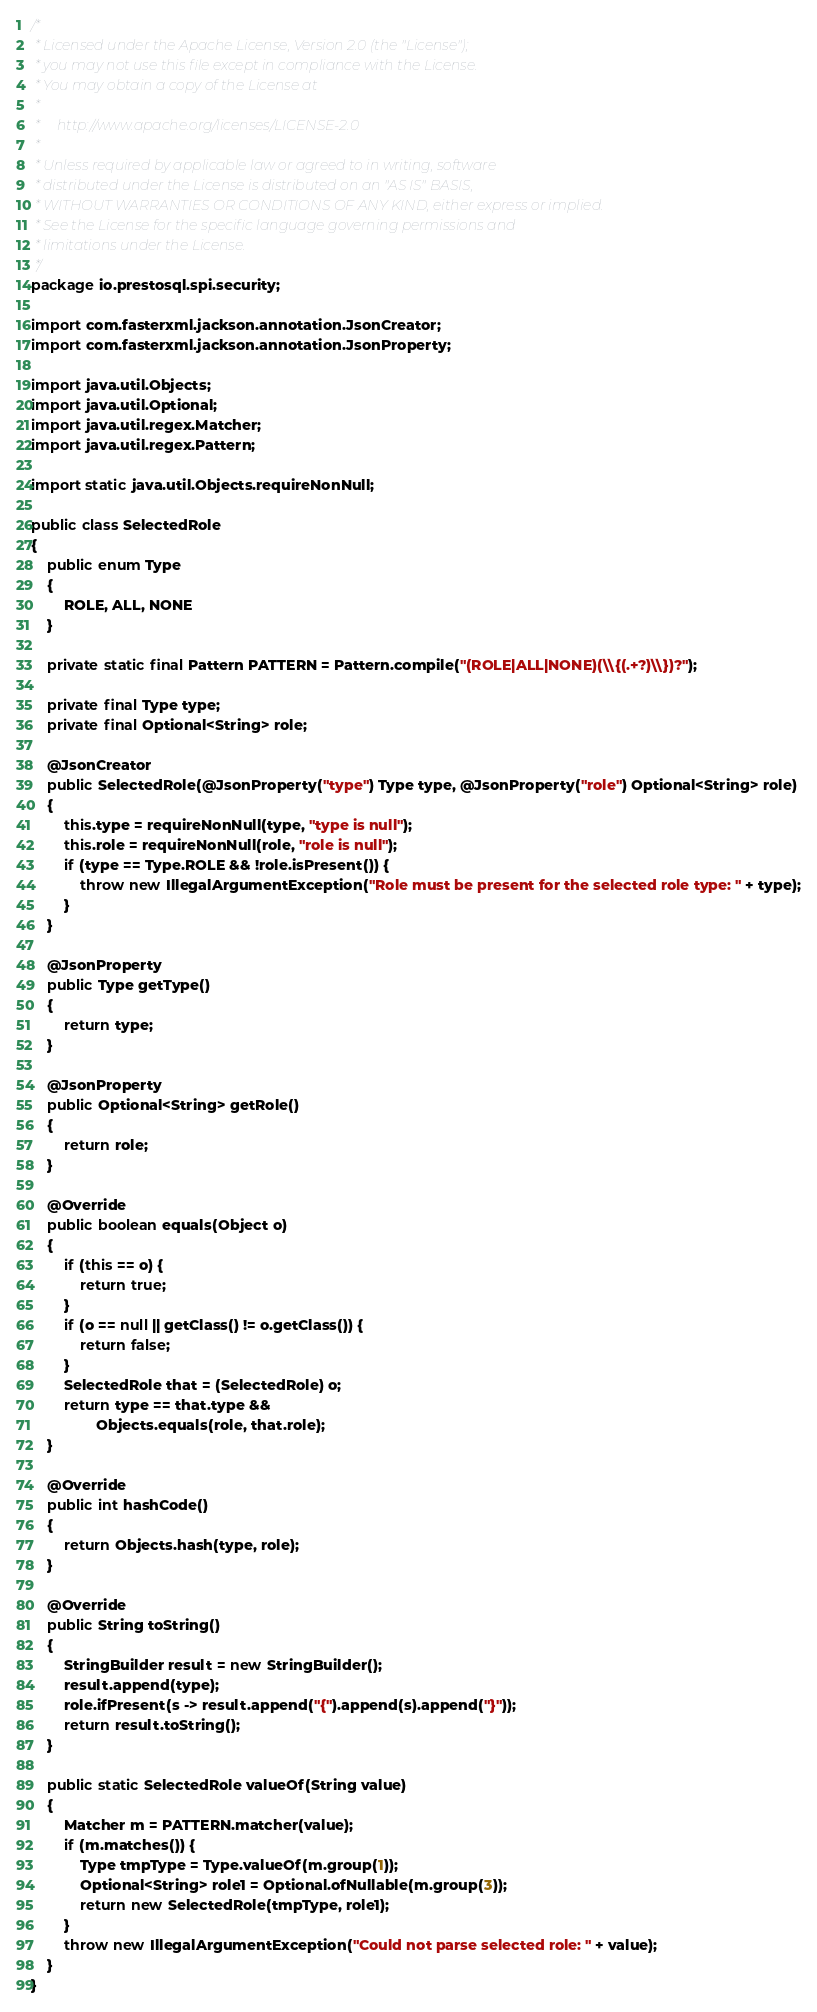<code> <loc_0><loc_0><loc_500><loc_500><_Java_>/*
 * Licensed under the Apache License, Version 2.0 (the "License");
 * you may not use this file except in compliance with the License.
 * You may obtain a copy of the License at
 *
 *     http://www.apache.org/licenses/LICENSE-2.0
 *
 * Unless required by applicable law or agreed to in writing, software
 * distributed under the License is distributed on an "AS IS" BASIS,
 * WITHOUT WARRANTIES OR CONDITIONS OF ANY KIND, either express or implied.
 * See the License for the specific language governing permissions and
 * limitations under the License.
 */
package io.prestosql.spi.security;

import com.fasterxml.jackson.annotation.JsonCreator;
import com.fasterxml.jackson.annotation.JsonProperty;

import java.util.Objects;
import java.util.Optional;
import java.util.regex.Matcher;
import java.util.regex.Pattern;

import static java.util.Objects.requireNonNull;

public class SelectedRole
{
    public enum Type
    {
        ROLE, ALL, NONE
    }

    private static final Pattern PATTERN = Pattern.compile("(ROLE|ALL|NONE)(\\{(.+?)\\})?");

    private final Type type;
    private final Optional<String> role;

    @JsonCreator
    public SelectedRole(@JsonProperty("type") Type type, @JsonProperty("role") Optional<String> role)
    {
        this.type = requireNonNull(type, "type is null");
        this.role = requireNonNull(role, "role is null");
        if (type == Type.ROLE && !role.isPresent()) {
            throw new IllegalArgumentException("Role must be present for the selected role type: " + type);
        }
    }

    @JsonProperty
    public Type getType()
    {
        return type;
    }

    @JsonProperty
    public Optional<String> getRole()
    {
        return role;
    }

    @Override
    public boolean equals(Object o)
    {
        if (this == o) {
            return true;
        }
        if (o == null || getClass() != o.getClass()) {
            return false;
        }
        SelectedRole that = (SelectedRole) o;
        return type == that.type &&
                Objects.equals(role, that.role);
    }

    @Override
    public int hashCode()
    {
        return Objects.hash(type, role);
    }

    @Override
    public String toString()
    {
        StringBuilder result = new StringBuilder();
        result.append(type);
        role.ifPresent(s -> result.append("{").append(s).append("}"));
        return result.toString();
    }

    public static SelectedRole valueOf(String value)
    {
        Matcher m = PATTERN.matcher(value);
        if (m.matches()) {
            Type tmpType = Type.valueOf(m.group(1));
            Optional<String> role1 = Optional.ofNullable(m.group(3));
            return new SelectedRole(tmpType, role1);
        }
        throw new IllegalArgumentException("Could not parse selected role: " + value);
    }
}
</code> 